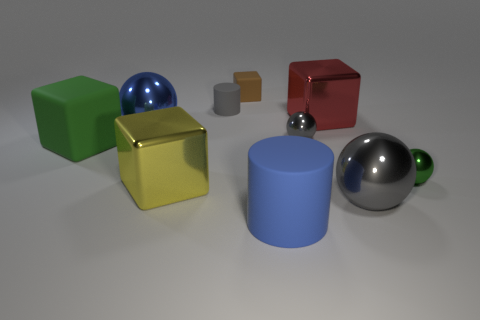Subtract all cylinders. How many objects are left? 8 Add 7 big yellow cubes. How many big yellow cubes are left? 8 Add 6 rubber objects. How many rubber objects exist? 10 Subtract 1 green blocks. How many objects are left? 9 Subtract all blue metal things. Subtract all large yellow metal blocks. How many objects are left? 8 